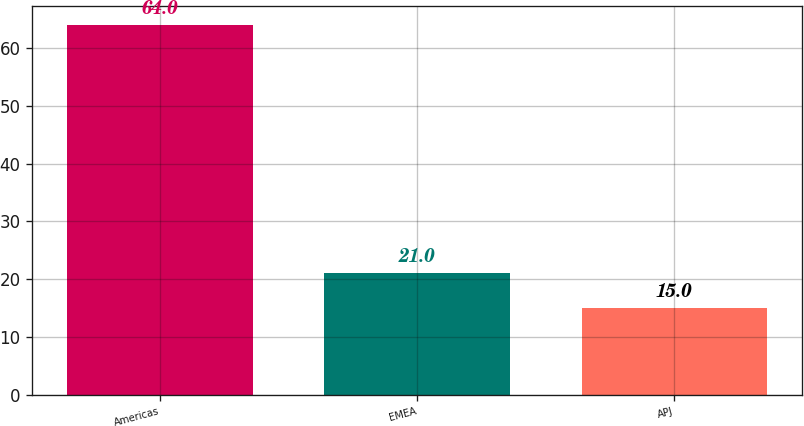Convert chart to OTSL. <chart><loc_0><loc_0><loc_500><loc_500><bar_chart><fcel>Americas<fcel>EMEA<fcel>APJ<nl><fcel>64<fcel>21<fcel>15<nl></chart> 